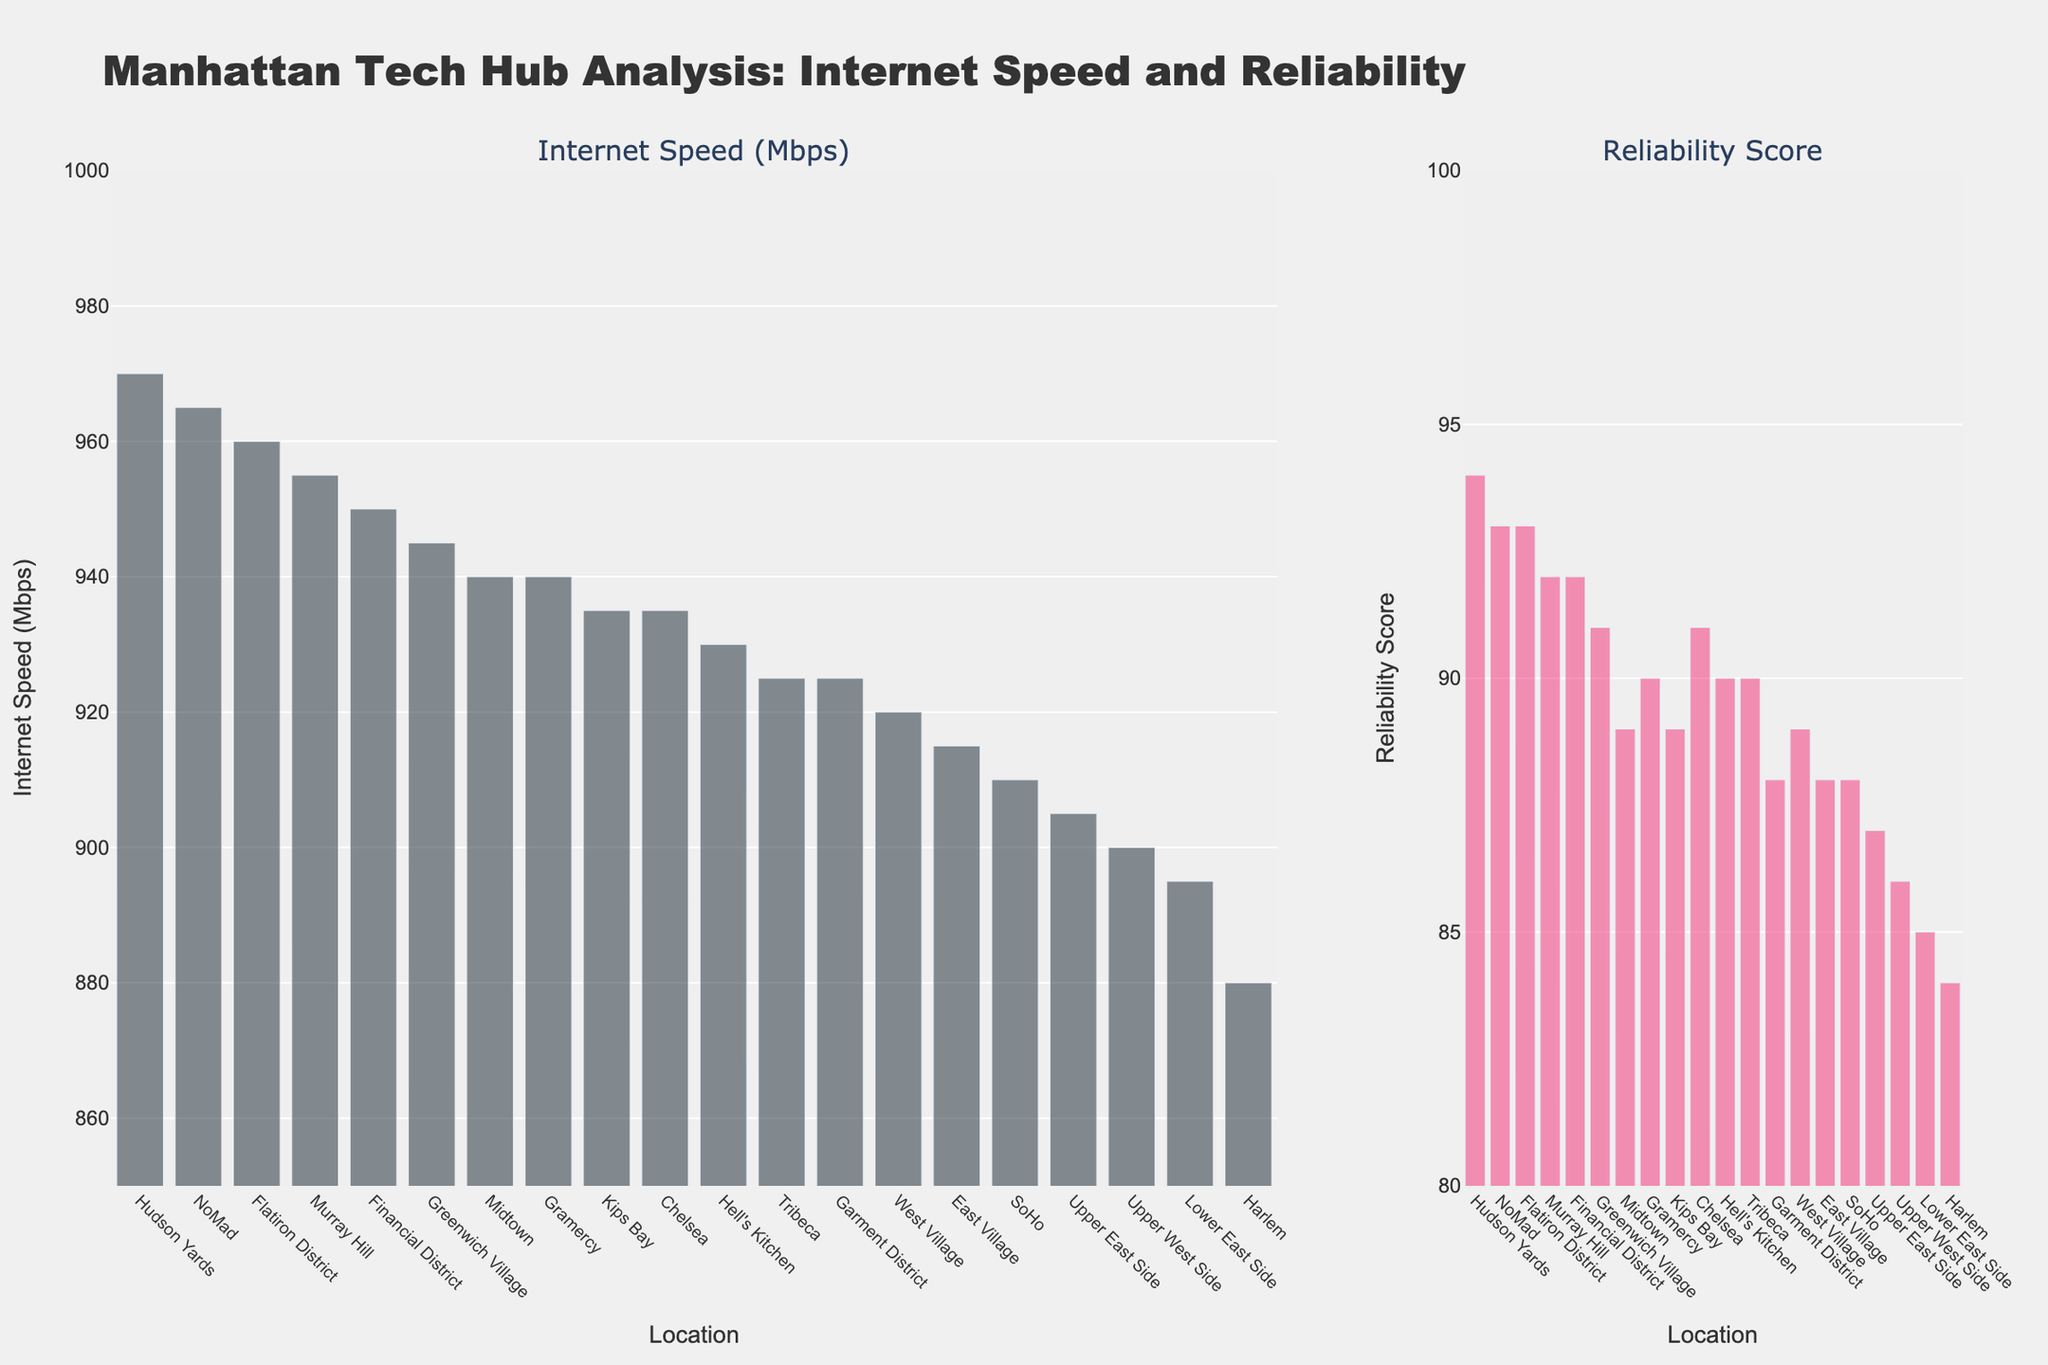What's the title of the figure? The title of a figure is typically displayed at the top and gives an overview of what the figure represents. Here, it clearly states "Manhattan Tech Hub Analysis: Internet Speed and Reliability."
Answer: Manhattan Tech Hub Analysis: Internet Speed and Reliability Which area has the highest Internet speed? The highest Internet speed is indicated by the tallest bar under the "Internet Speed (Mbps)" subplot. The tallest bar corresponds to Hudson Yards.
Answer: Hudson Yards How many areas have Internet speeds greater than 950 Mbps? Count the bars in the "Internet Speed (Mbps)" subplot that exceed the 950 mark. The areas are Financial District, Flatiron District, Murray Hill, NoMad, and Hudson Yards, totaling 5.
Answer: 5 What is the Internet speed difference between the Financial District and Harlem? Look at the heights of the bars corresponding to Financial District and Harlem under the "Internet Speed (Mbps)" subplot. Financial District is 950 Mbps, and Harlem is 880 Mbps. The difference is 950 - 880 = 70 Mbps.
Answer: 70 Mbps Which area has the lowest reliability score? The lowest reliability score is indicated by the shortest bar under the "Reliability Score" subplot. The shortest bar corresponds to Harlem.
Answer: Harlem Is Chelsea's reliability score higher than the Upper West Side's? Compare the heights of the bars corresponding to Chelsea and Upper West Side in the "Reliability Score" subplot. Chelsea has a reliability score of 91, while Upper West Side has 86.
Answer: Yes What is the average Internet speed for the top 5 areas? The top 5 areas by Internet speed are sorted in descending order: Hudson Yards (970), NoMad (965), Flatiron District (960), Murray Hill (955), and Financial District (950). The average is (970 + 965 + 960 + 955 + 950) / 5. Calculate this to get the average speed.
Answer: 960 Mbps Which area has the smallest difference between its Internet speed and reliability score? Calculate the difference for each area and find the smallest. For example, Financial District's difference is 950 - 92 = 858. Repeat for all areas and compare.
Answer: Gramercy (950 - 93 = 847) Which area ranks third in reliability score? Rank the areas by their reliability scores in descending order. The third highest area is Flatiron District with a reliability score of 91.
Answer: Flatiron District Does East Village have a higher Internet speed than West Village? Compare the Internet speeds of East Village (915 Mbps) and West Village (920 Mbps).
Answer: No 